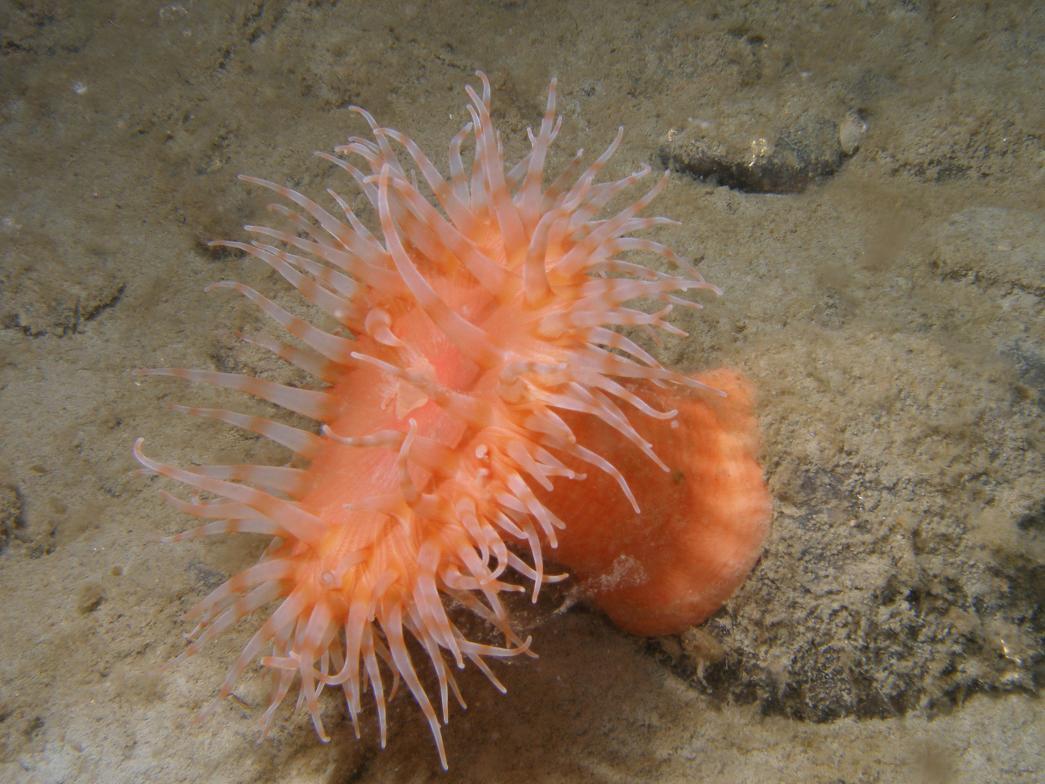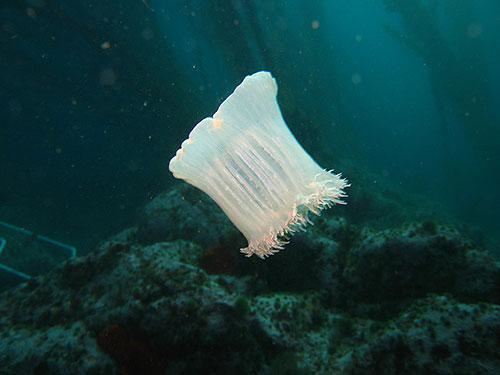The first image is the image on the left, the second image is the image on the right. Considering the images on both sides, is "At least one image shows fish swimming around a sea anemone." valid? Answer yes or no. No. The first image is the image on the left, the second image is the image on the right. Given the left and right images, does the statement "One of the two images shows more than one of the same species of free-swimming fish." hold true? Answer yes or no. No. 